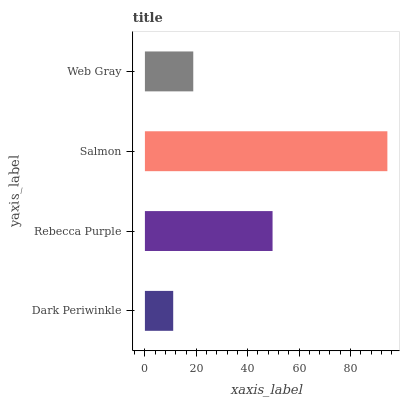Is Dark Periwinkle the minimum?
Answer yes or no. Yes. Is Salmon the maximum?
Answer yes or no. Yes. Is Rebecca Purple the minimum?
Answer yes or no. No. Is Rebecca Purple the maximum?
Answer yes or no. No. Is Rebecca Purple greater than Dark Periwinkle?
Answer yes or no. Yes. Is Dark Periwinkle less than Rebecca Purple?
Answer yes or no. Yes. Is Dark Periwinkle greater than Rebecca Purple?
Answer yes or no. No. Is Rebecca Purple less than Dark Periwinkle?
Answer yes or no. No. Is Rebecca Purple the high median?
Answer yes or no. Yes. Is Web Gray the low median?
Answer yes or no. Yes. Is Salmon the high median?
Answer yes or no. No. Is Rebecca Purple the low median?
Answer yes or no. No. 